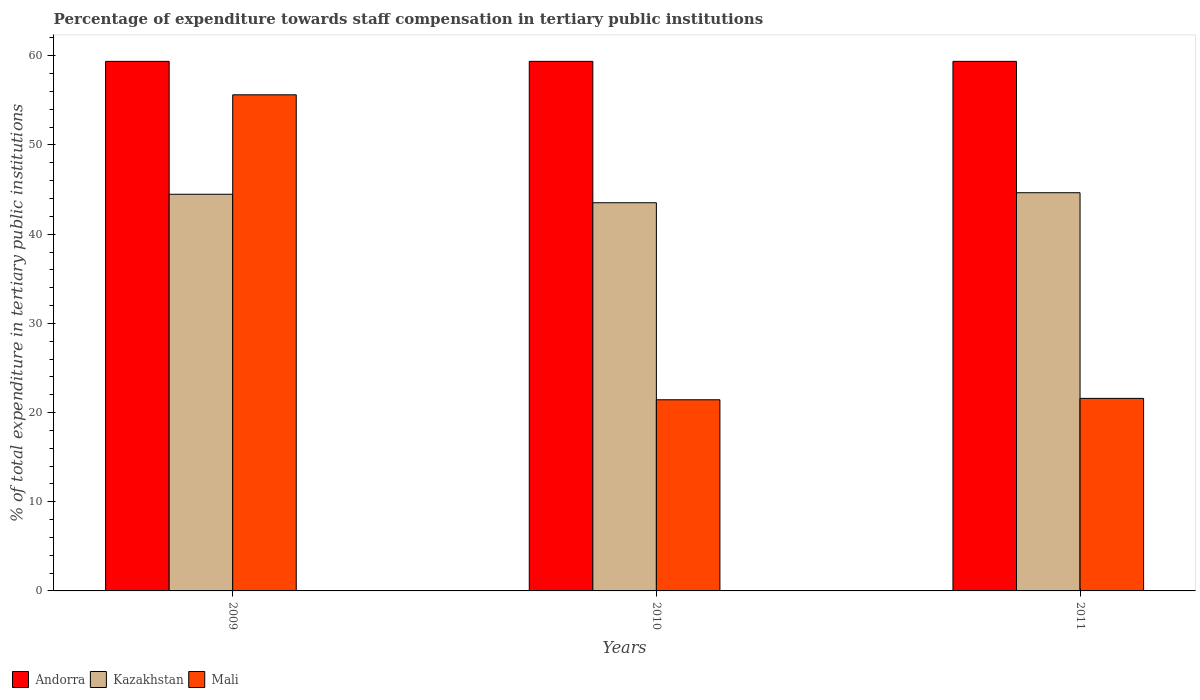How many groups of bars are there?
Ensure brevity in your answer.  3. Are the number of bars on each tick of the X-axis equal?
Keep it short and to the point. Yes. What is the percentage of expenditure towards staff compensation in Kazakhstan in 2009?
Offer a terse response. 44.48. Across all years, what is the maximum percentage of expenditure towards staff compensation in Kazakhstan?
Your answer should be very brief. 44.65. Across all years, what is the minimum percentage of expenditure towards staff compensation in Kazakhstan?
Make the answer very short. 43.52. In which year was the percentage of expenditure towards staff compensation in Andorra maximum?
Ensure brevity in your answer.  2009. In which year was the percentage of expenditure towards staff compensation in Mali minimum?
Make the answer very short. 2010. What is the total percentage of expenditure towards staff compensation in Mali in the graph?
Offer a terse response. 98.65. What is the difference between the percentage of expenditure towards staff compensation in Mali in 2009 and that in 2011?
Provide a short and direct response. 34.04. What is the difference between the percentage of expenditure towards staff compensation in Andorra in 2011 and the percentage of expenditure towards staff compensation in Kazakhstan in 2009?
Keep it short and to the point. 14.9. What is the average percentage of expenditure towards staff compensation in Kazakhstan per year?
Give a very brief answer. 44.22. In the year 2009, what is the difference between the percentage of expenditure towards staff compensation in Mali and percentage of expenditure towards staff compensation in Kazakhstan?
Give a very brief answer. 11.15. In how many years, is the percentage of expenditure towards staff compensation in Andorra greater than 8 %?
Your answer should be very brief. 3. What is the ratio of the percentage of expenditure towards staff compensation in Kazakhstan in 2010 to that in 2011?
Your answer should be compact. 0.97. Is the percentage of expenditure towards staff compensation in Mali in 2009 less than that in 2010?
Ensure brevity in your answer.  No. What is the difference between the highest and the second highest percentage of expenditure towards staff compensation in Mali?
Give a very brief answer. 34.04. What is the difference between the highest and the lowest percentage of expenditure towards staff compensation in Andorra?
Your answer should be very brief. 0. Is the sum of the percentage of expenditure towards staff compensation in Mali in 2010 and 2011 greater than the maximum percentage of expenditure towards staff compensation in Andorra across all years?
Offer a very short reply. No. What does the 2nd bar from the left in 2010 represents?
Your response must be concise. Kazakhstan. What does the 2nd bar from the right in 2010 represents?
Your answer should be compact. Kazakhstan. How many bars are there?
Provide a short and direct response. 9. Are all the bars in the graph horizontal?
Make the answer very short. No. How many years are there in the graph?
Offer a very short reply. 3. What is the difference between two consecutive major ticks on the Y-axis?
Your response must be concise. 10. Does the graph contain any zero values?
Offer a terse response. No. Does the graph contain grids?
Provide a short and direct response. No. How many legend labels are there?
Provide a short and direct response. 3. What is the title of the graph?
Provide a succinct answer. Percentage of expenditure towards staff compensation in tertiary public institutions. What is the label or title of the X-axis?
Ensure brevity in your answer.  Years. What is the label or title of the Y-axis?
Your response must be concise. % of total expenditure in tertiary public institutions. What is the % of total expenditure in tertiary public institutions in Andorra in 2009?
Your answer should be very brief. 59.38. What is the % of total expenditure in tertiary public institutions of Kazakhstan in 2009?
Ensure brevity in your answer.  44.48. What is the % of total expenditure in tertiary public institutions in Mali in 2009?
Your response must be concise. 55.63. What is the % of total expenditure in tertiary public institutions of Andorra in 2010?
Keep it short and to the point. 59.38. What is the % of total expenditure in tertiary public institutions in Kazakhstan in 2010?
Provide a succinct answer. 43.52. What is the % of total expenditure in tertiary public institutions in Mali in 2010?
Ensure brevity in your answer.  21.43. What is the % of total expenditure in tertiary public institutions in Andorra in 2011?
Offer a terse response. 59.38. What is the % of total expenditure in tertiary public institutions in Kazakhstan in 2011?
Provide a succinct answer. 44.65. What is the % of total expenditure in tertiary public institutions of Mali in 2011?
Give a very brief answer. 21.59. Across all years, what is the maximum % of total expenditure in tertiary public institutions in Andorra?
Give a very brief answer. 59.38. Across all years, what is the maximum % of total expenditure in tertiary public institutions in Kazakhstan?
Ensure brevity in your answer.  44.65. Across all years, what is the maximum % of total expenditure in tertiary public institutions in Mali?
Provide a succinct answer. 55.63. Across all years, what is the minimum % of total expenditure in tertiary public institutions in Andorra?
Your response must be concise. 59.38. Across all years, what is the minimum % of total expenditure in tertiary public institutions in Kazakhstan?
Your response must be concise. 43.52. Across all years, what is the minimum % of total expenditure in tertiary public institutions of Mali?
Provide a short and direct response. 21.43. What is the total % of total expenditure in tertiary public institutions of Andorra in the graph?
Provide a short and direct response. 178.13. What is the total % of total expenditure in tertiary public institutions of Kazakhstan in the graph?
Make the answer very short. 132.65. What is the total % of total expenditure in tertiary public institutions of Mali in the graph?
Give a very brief answer. 98.65. What is the difference between the % of total expenditure in tertiary public institutions in Kazakhstan in 2009 and that in 2010?
Ensure brevity in your answer.  0.95. What is the difference between the % of total expenditure in tertiary public institutions of Mali in 2009 and that in 2010?
Make the answer very short. 34.2. What is the difference between the % of total expenditure in tertiary public institutions of Andorra in 2009 and that in 2011?
Offer a terse response. 0. What is the difference between the % of total expenditure in tertiary public institutions in Kazakhstan in 2009 and that in 2011?
Provide a short and direct response. -0.17. What is the difference between the % of total expenditure in tertiary public institutions of Mali in 2009 and that in 2011?
Provide a succinct answer. 34.04. What is the difference between the % of total expenditure in tertiary public institutions of Kazakhstan in 2010 and that in 2011?
Keep it short and to the point. -1.12. What is the difference between the % of total expenditure in tertiary public institutions in Mali in 2010 and that in 2011?
Provide a succinct answer. -0.16. What is the difference between the % of total expenditure in tertiary public institutions of Andorra in 2009 and the % of total expenditure in tertiary public institutions of Kazakhstan in 2010?
Offer a very short reply. 15.85. What is the difference between the % of total expenditure in tertiary public institutions of Andorra in 2009 and the % of total expenditure in tertiary public institutions of Mali in 2010?
Offer a very short reply. 37.95. What is the difference between the % of total expenditure in tertiary public institutions in Kazakhstan in 2009 and the % of total expenditure in tertiary public institutions in Mali in 2010?
Your answer should be very brief. 23.04. What is the difference between the % of total expenditure in tertiary public institutions of Andorra in 2009 and the % of total expenditure in tertiary public institutions of Kazakhstan in 2011?
Your response must be concise. 14.73. What is the difference between the % of total expenditure in tertiary public institutions of Andorra in 2009 and the % of total expenditure in tertiary public institutions of Mali in 2011?
Make the answer very short. 37.79. What is the difference between the % of total expenditure in tertiary public institutions in Kazakhstan in 2009 and the % of total expenditure in tertiary public institutions in Mali in 2011?
Provide a short and direct response. 22.89. What is the difference between the % of total expenditure in tertiary public institutions of Andorra in 2010 and the % of total expenditure in tertiary public institutions of Kazakhstan in 2011?
Provide a succinct answer. 14.73. What is the difference between the % of total expenditure in tertiary public institutions of Andorra in 2010 and the % of total expenditure in tertiary public institutions of Mali in 2011?
Ensure brevity in your answer.  37.79. What is the difference between the % of total expenditure in tertiary public institutions in Kazakhstan in 2010 and the % of total expenditure in tertiary public institutions in Mali in 2011?
Your answer should be compact. 21.94. What is the average % of total expenditure in tertiary public institutions of Andorra per year?
Provide a short and direct response. 59.38. What is the average % of total expenditure in tertiary public institutions of Kazakhstan per year?
Your answer should be very brief. 44.22. What is the average % of total expenditure in tertiary public institutions in Mali per year?
Offer a very short reply. 32.88. In the year 2009, what is the difference between the % of total expenditure in tertiary public institutions of Andorra and % of total expenditure in tertiary public institutions of Kazakhstan?
Keep it short and to the point. 14.9. In the year 2009, what is the difference between the % of total expenditure in tertiary public institutions in Andorra and % of total expenditure in tertiary public institutions in Mali?
Offer a very short reply. 3.75. In the year 2009, what is the difference between the % of total expenditure in tertiary public institutions of Kazakhstan and % of total expenditure in tertiary public institutions of Mali?
Give a very brief answer. -11.15. In the year 2010, what is the difference between the % of total expenditure in tertiary public institutions of Andorra and % of total expenditure in tertiary public institutions of Kazakhstan?
Your response must be concise. 15.85. In the year 2010, what is the difference between the % of total expenditure in tertiary public institutions of Andorra and % of total expenditure in tertiary public institutions of Mali?
Offer a very short reply. 37.95. In the year 2010, what is the difference between the % of total expenditure in tertiary public institutions in Kazakhstan and % of total expenditure in tertiary public institutions in Mali?
Ensure brevity in your answer.  22.09. In the year 2011, what is the difference between the % of total expenditure in tertiary public institutions in Andorra and % of total expenditure in tertiary public institutions in Kazakhstan?
Provide a succinct answer. 14.73. In the year 2011, what is the difference between the % of total expenditure in tertiary public institutions in Andorra and % of total expenditure in tertiary public institutions in Mali?
Give a very brief answer. 37.79. In the year 2011, what is the difference between the % of total expenditure in tertiary public institutions of Kazakhstan and % of total expenditure in tertiary public institutions of Mali?
Your answer should be compact. 23.06. What is the ratio of the % of total expenditure in tertiary public institutions of Andorra in 2009 to that in 2010?
Your response must be concise. 1. What is the ratio of the % of total expenditure in tertiary public institutions of Kazakhstan in 2009 to that in 2010?
Your answer should be very brief. 1.02. What is the ratio of the % of total expenditure in tertiary public institutions in Mali in 2009 to that in 2010?
Ensure brevity in your answer.  2.6. What is the ratio of the % of total expenditure in tertiary public institutions in Andorra in 2009 to that in 2011?
Provide a short and direct response. 1. What is the ratio of the % of total expenditure in tertiary public institutions of Mali in 2009 to that in 2011?
Provide a succinct answer. 2.58. What is the ratio of the % of total expenditure in tertiary public institutions of Andorra in 2010 to that in 2011?
Provide a succinct answer. 1. What is the ratio of the % of total expenditure in tertiary public institutions in Kazakhstan in 2010 to that in 2011?
Your answer should be compact. 0.97. What is the ratio of the % of total expenditure in tertiary public institutions in Mali in 2010 to that in 2011?
Your response must be concise. 0.99. What is the difference between the highest and the second highest % of total expenditure in tertiary public institutions of Andorra?
Give a very brief answer. 0. What is the difference between the highest and the second highest % of total expenditure in tertiary public institutions of Kazakhstan?
Your answer should be compact. 0.17. What is the difference between the highest and the second highest % of total expenditure in tertiary public institutions of Mali?
Give a very brief answer. 34.04. What is the difference between the highest and the lowest % of total expenditure in tertiary public institutions in Kazakhstan?
Keep it short and to the point. 1.12. What is the difference between the highest and the lowest % of total expenditure in tertiary public institutions of Mali?
Provide a short and direct response. 34.2. 